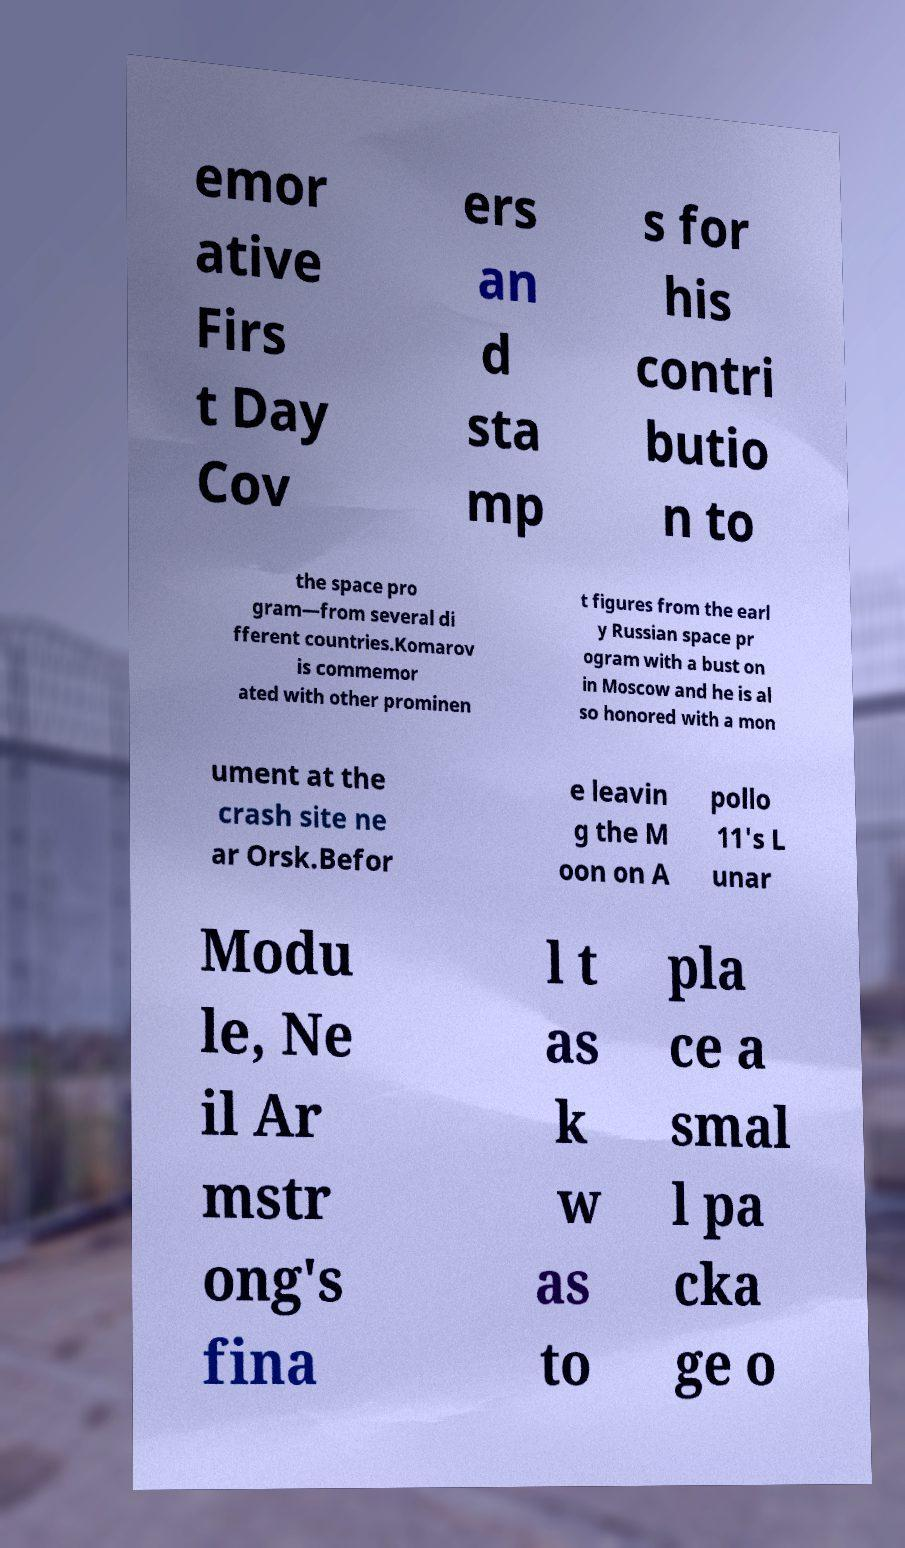What messages or text are displayed in this image? I need them in a readable, typed format. emor ative Firs t Day Cov ers an d sta mp s for his contri butio n to the space pro gram—from several di fferent countries.Komarov is commemor ated with other prominen t figures from the earl y Russian space pr ogram with a bust on in Moscow and he is al so honored with a mon ument at the crash site ne ar Orsk.Befor e leavin g the M oon on A pollo 11's L unar Modu le, Ne il Ar mstr ong's fina l t as k w as to pla ce a smal l pa cka ge o 